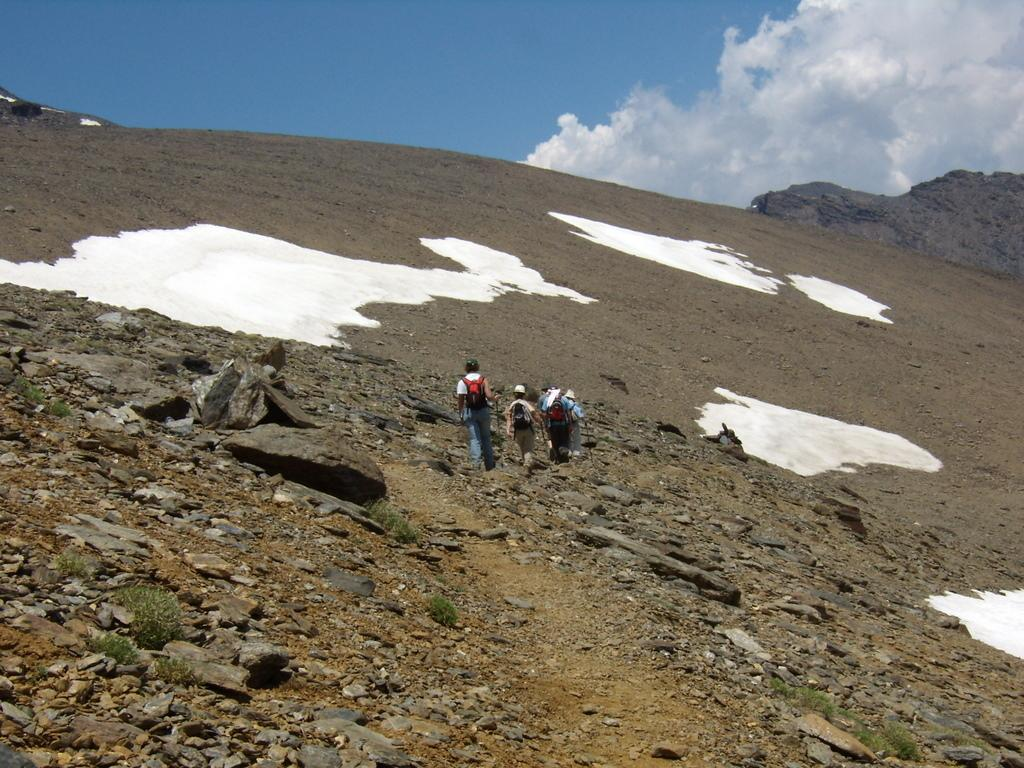What are the people in the image doing? The people in the image are walking. What are the people wearing on their heads? The people are wearing caps. What are the people carrying on their backs? The people are carrying bags on their backs. What type of terrain can be seen in the image? There are stones and grass in the image. What is the weather like in the image? The sky is cloudy, and there is snow in the image. What arithmetic problem is being solved by the sock in the image? There is no sock present in the image, and therefore no arithmetic problem can be solved by it. How does the cough affect the people walking in the image? There is no mention of a cough in the image, so it cannot affect the people walking. 